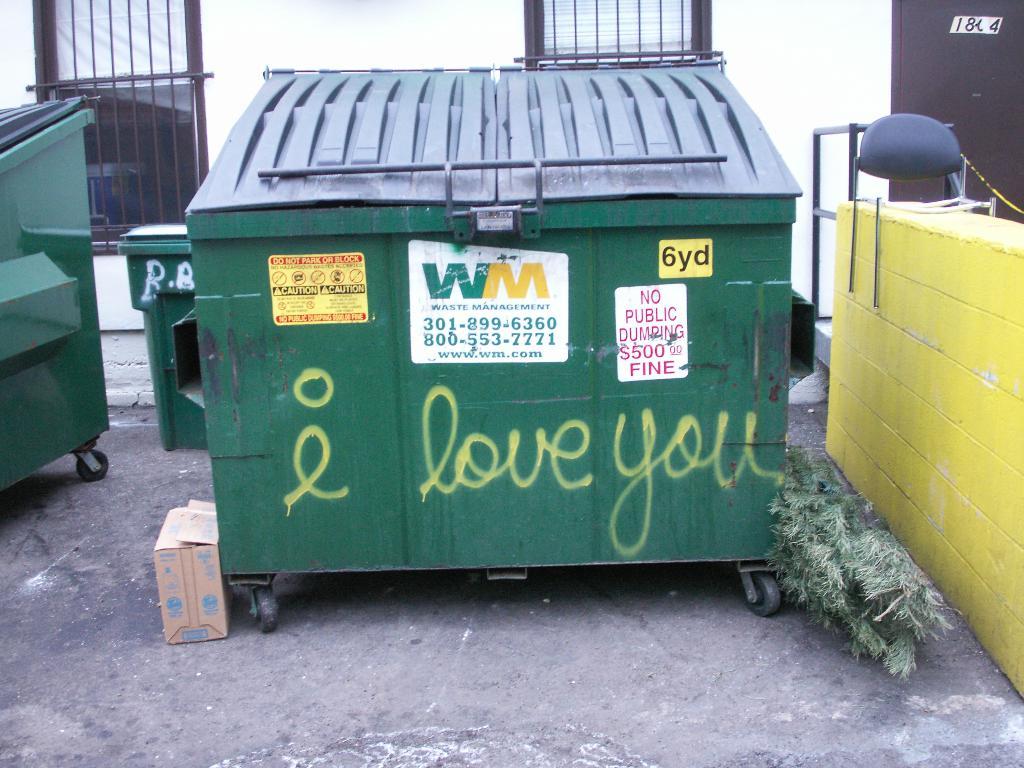How much is the fine for public dumping?
Your answer should be compact. $500. What is written in spray paint on the can?
Your answer should be very brief. I love you. 